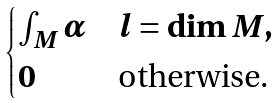Convert formula to latex. <formula><loc_0><loc_0><loc_500><loc_500>\begin{cases} \int _ { M } \alpha & l = \dim M , \\ 0 & \text {otherwise.} \end{cases}</formula> 